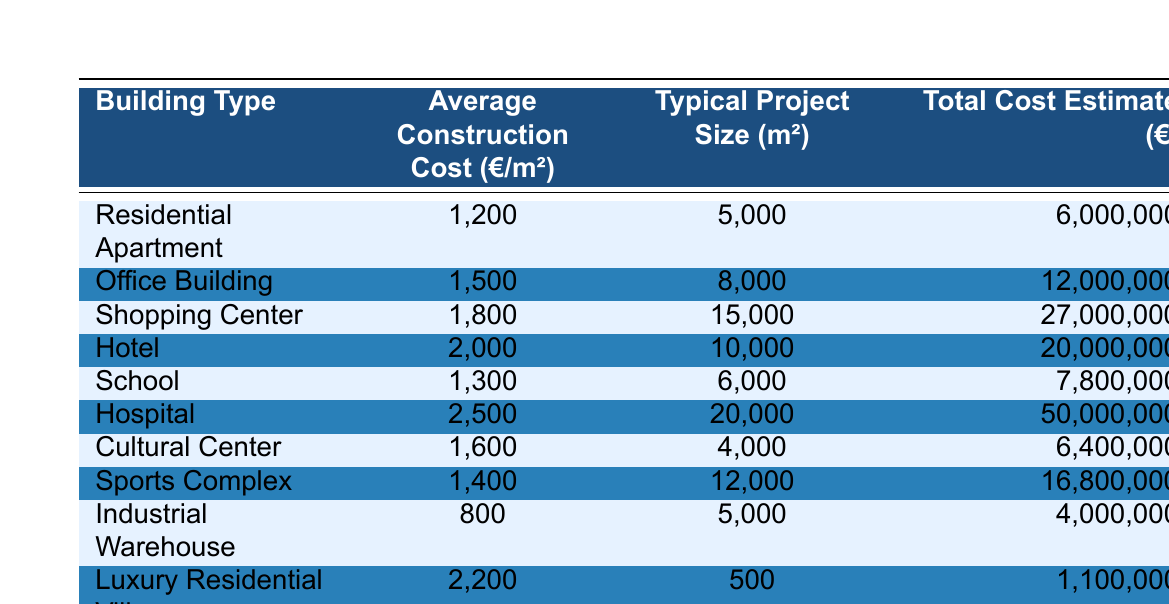What is the average construction cost per square meter for a Hospital? The table shows the average construction cost for a Hospital listed as 2500 €/m².
Answer: 2500 €/m² What is the total cost estimate for constructing a Shopping Center? According to the table, the total cost estimate for a Shopping Center is 27,000,000 €.
Answer: 27,000,000 € Which building type has the highest average construction cost? The table indicates that the Hospital has the highest average construction cost at 2500 €/m².
Answer: Hospital What is the total cost estimate if you build 10 Residential Apartments? Each Residential Apartment has a total cost estimate of 6,000,000 €. If we build 10, the total estimate is 10 x 6,000,000 € = 60,000,000 €.
Answer: 60,000,000 € What is the average construction cost of all the buildings listed in the table? To find the average, sum the average costs of all building types: (1200 + 1500 + 1800 + 2000 + 1300 + 2500 + 1600 + 1400 + 800 + 2200) = 13,000, divide by 10 (the number of types) to get 1300 €.
Answer: 1300 €/m² Do all building types have a total cost estimate above 5 million euros? The table shows that the Industrial Warehouse has a total cost estimate of 4,000,000 €, which is below 5 million.
Answer: No What is the difference in average construction cost between a Luxury Residential Villa and an Industrial Warehouse? The average construction cost for a Luxury Residential Villa is 2200 €/m² and for an Industrial Warehouse is 800 €/m². The difference is 2200 - 800 = 1400 €.
Answer: 1400 €/m² How much does it cost on average per square meter for a Sports Complex compared to a Cultural Center? The average cost for a Sports Complex is 1400 €/m² and for a Cultural Center is 1600 €/m². The difference shows that it is cheaper by 1600 - 1400 = 200 €.
Answer: 200 € cheaper What percentage of the total cost estimate does the School account for, compared to the sum of all total costs? The total cost estimate for School is 7,800,000 € and the sum of all total costs is 6,000,000 + 12,000,000 + 27,000,000 + 20,000,000 + 7,800,000 + 50,000,000 + 6,400,000 + 16,800,000 + 4,000,000 + 1,100,000 = 133,100,000 €. The percentage is (7,800,000 / 133,100,000) * 100 = approximately 5.86%.
Answer: Approximately 5.86% If you were to build a mixed-use project with equal space allocated to both a School and a Hospital, what would the total cost be? The typical size for a School is 6,000 m² and for a Hospital is 20,000 m². The total area would be 6,000 + 20,000 = 26,000 m². The total cost would be (1300 €/m² * 6,000 m²) + (2500 €/m² * 20,000 m²) = 7,800,000 € + 50,000,000 € = 57,800,000 €.
Answer: 57,800,000 € 